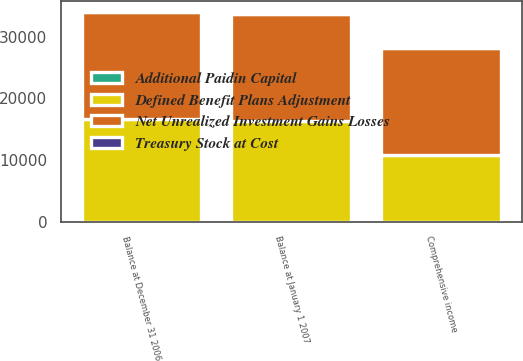Convert chart to OTSL. <chart><loc_0><loc_0><loc_500><loc_500><stacked_bar_chart><ecel><fcel>Comprehensive income<fcel>Balance at December 31 2006<fcel>Balance at January 1 2007<nl><fcel>Treasury Stock at Cost<fcel>1<fcel>1<fcel>1<nl><fcel>Additional Paidin Capital<fcel>8<fcel>8<fcel>8<nl><fcel>Net Unrealized Investment Gains Losses<fcel>17274<fcel>17454<fcel>17454<nl><fcel>Defined Benefit Plans Adjustment<fcel>10865<fcel>16574<fcel>16245<nl></chart> 